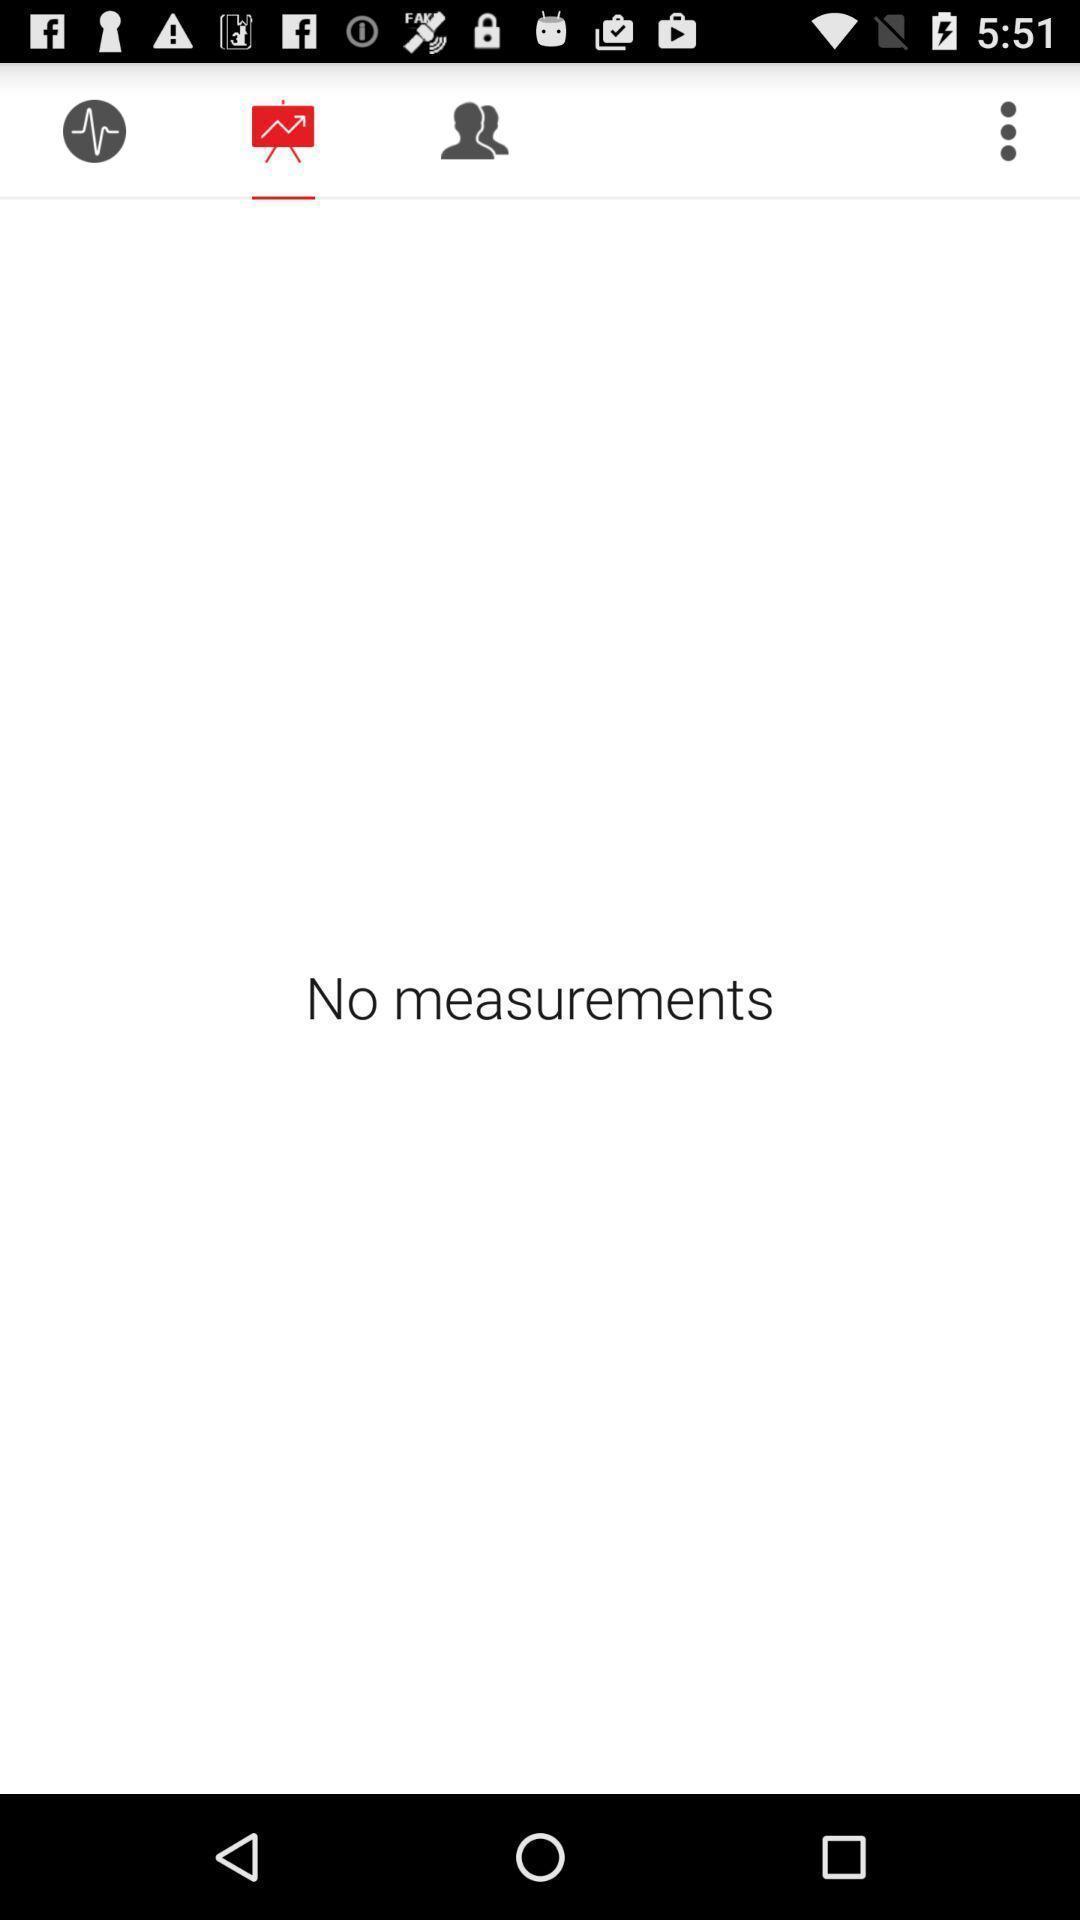Describe this image in words. Page showing of no measurements. 